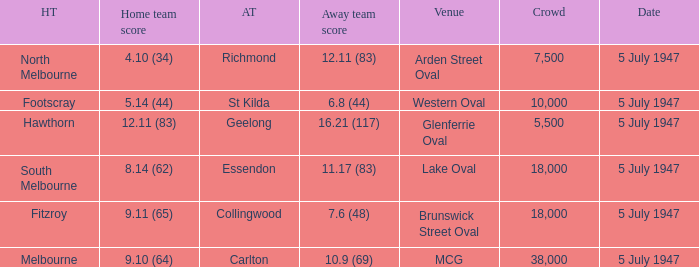Where was the game played where the away team has a score of 7.6 (48)? Brunswick Street Oval. 